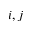Convert formula to latex. <formula><loc_0><loc_0><loc_500><loc_500>i , j</formula> 